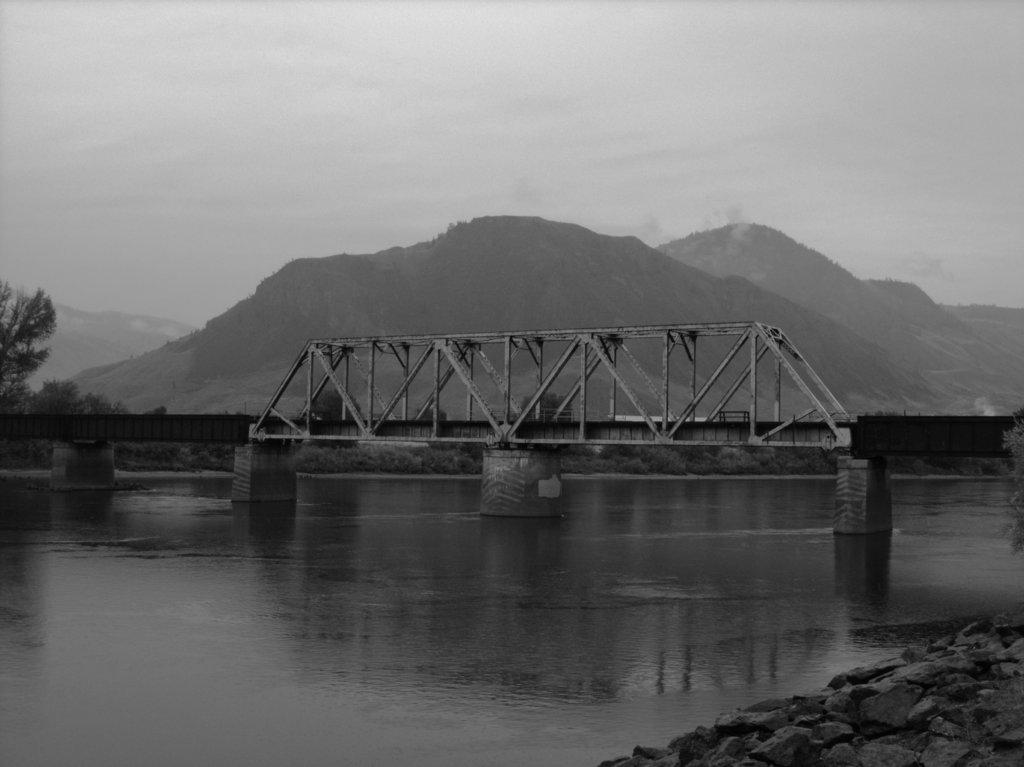What is the color scheme of the image? The image is black and white. What natural element can be seen in the image? There is water in the image. What type of geological feature is present in the image? There are rocks in the image. What man-made structure is visible in the image? There is a bridge in the image. What type of vegetation is present in the image? There are trees in the image. What type of landscape feature is present in the image? There are hills in the image. What is visible in the background of the image? The sky is visible in the background of the image. How many children are laughing in the image? There are no children or laughter present in the image. 